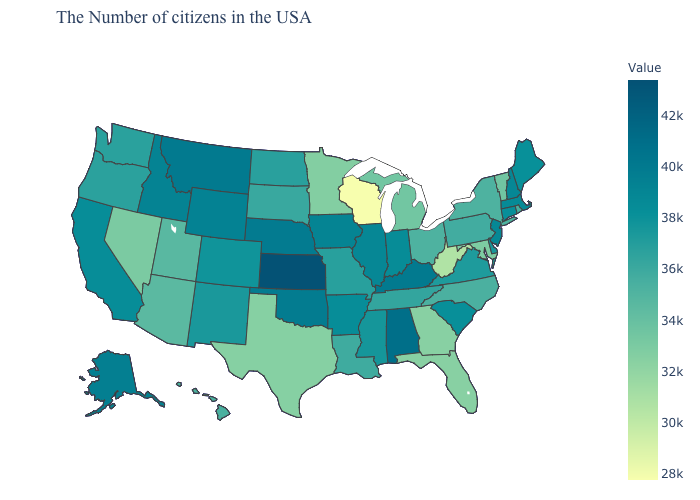Is the legend a continuous bar?
Concise answer only. Yes. Among the states that border Minnesota , which have the lowest value?
Give a very brief answer. Wisconsin. Does Montana have the highest value in the West?
Short answer required. Yes. 